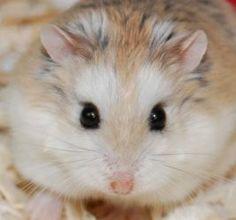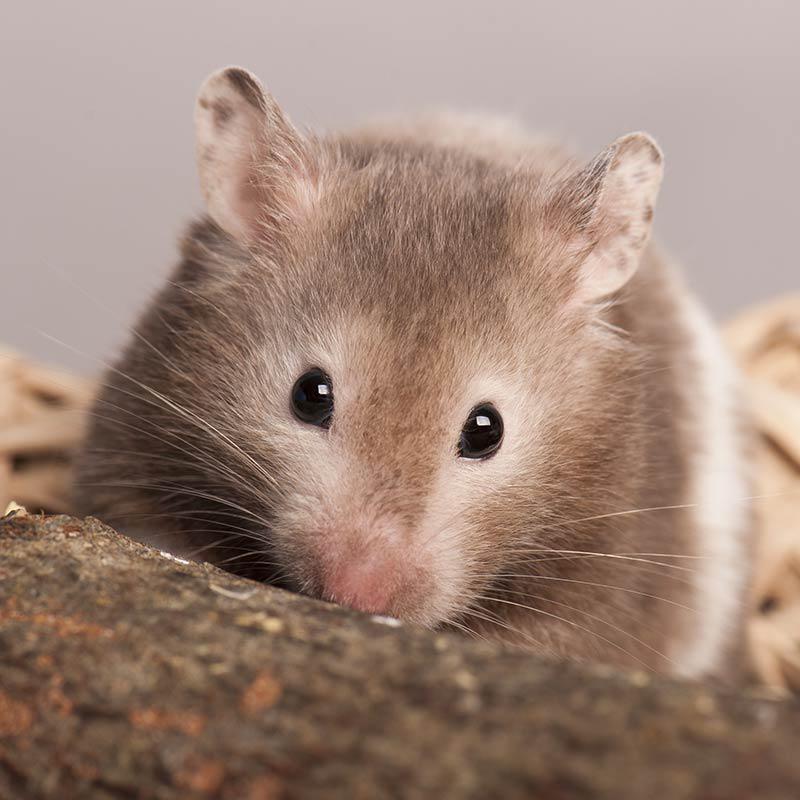The first image is the image on the left, the second image is the image on the right. Evaluate the accuracy of this statement regarding the images: "There are exactly 3 hamsters.". Is it true? Answer yes or no. No. The first image is the image on the left, the second image is the image on the right. Considering the images on both sides, is "The right image contains at least two rodents." valid? Answer yes or no. No. 